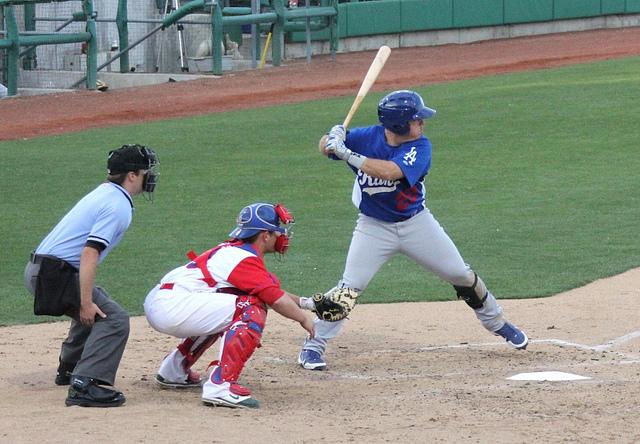What position does the squatting man play?
Concise answer only. Catcher. Is the umpire visible?
Keep it brief. Yes. Is the batter wearing protective gear?
Write a very short answer. Yes. What is the name of the team in blue?
Quick response, please. Royals. What color shirt is the umpire wearing?
Be succinct. Blue. 